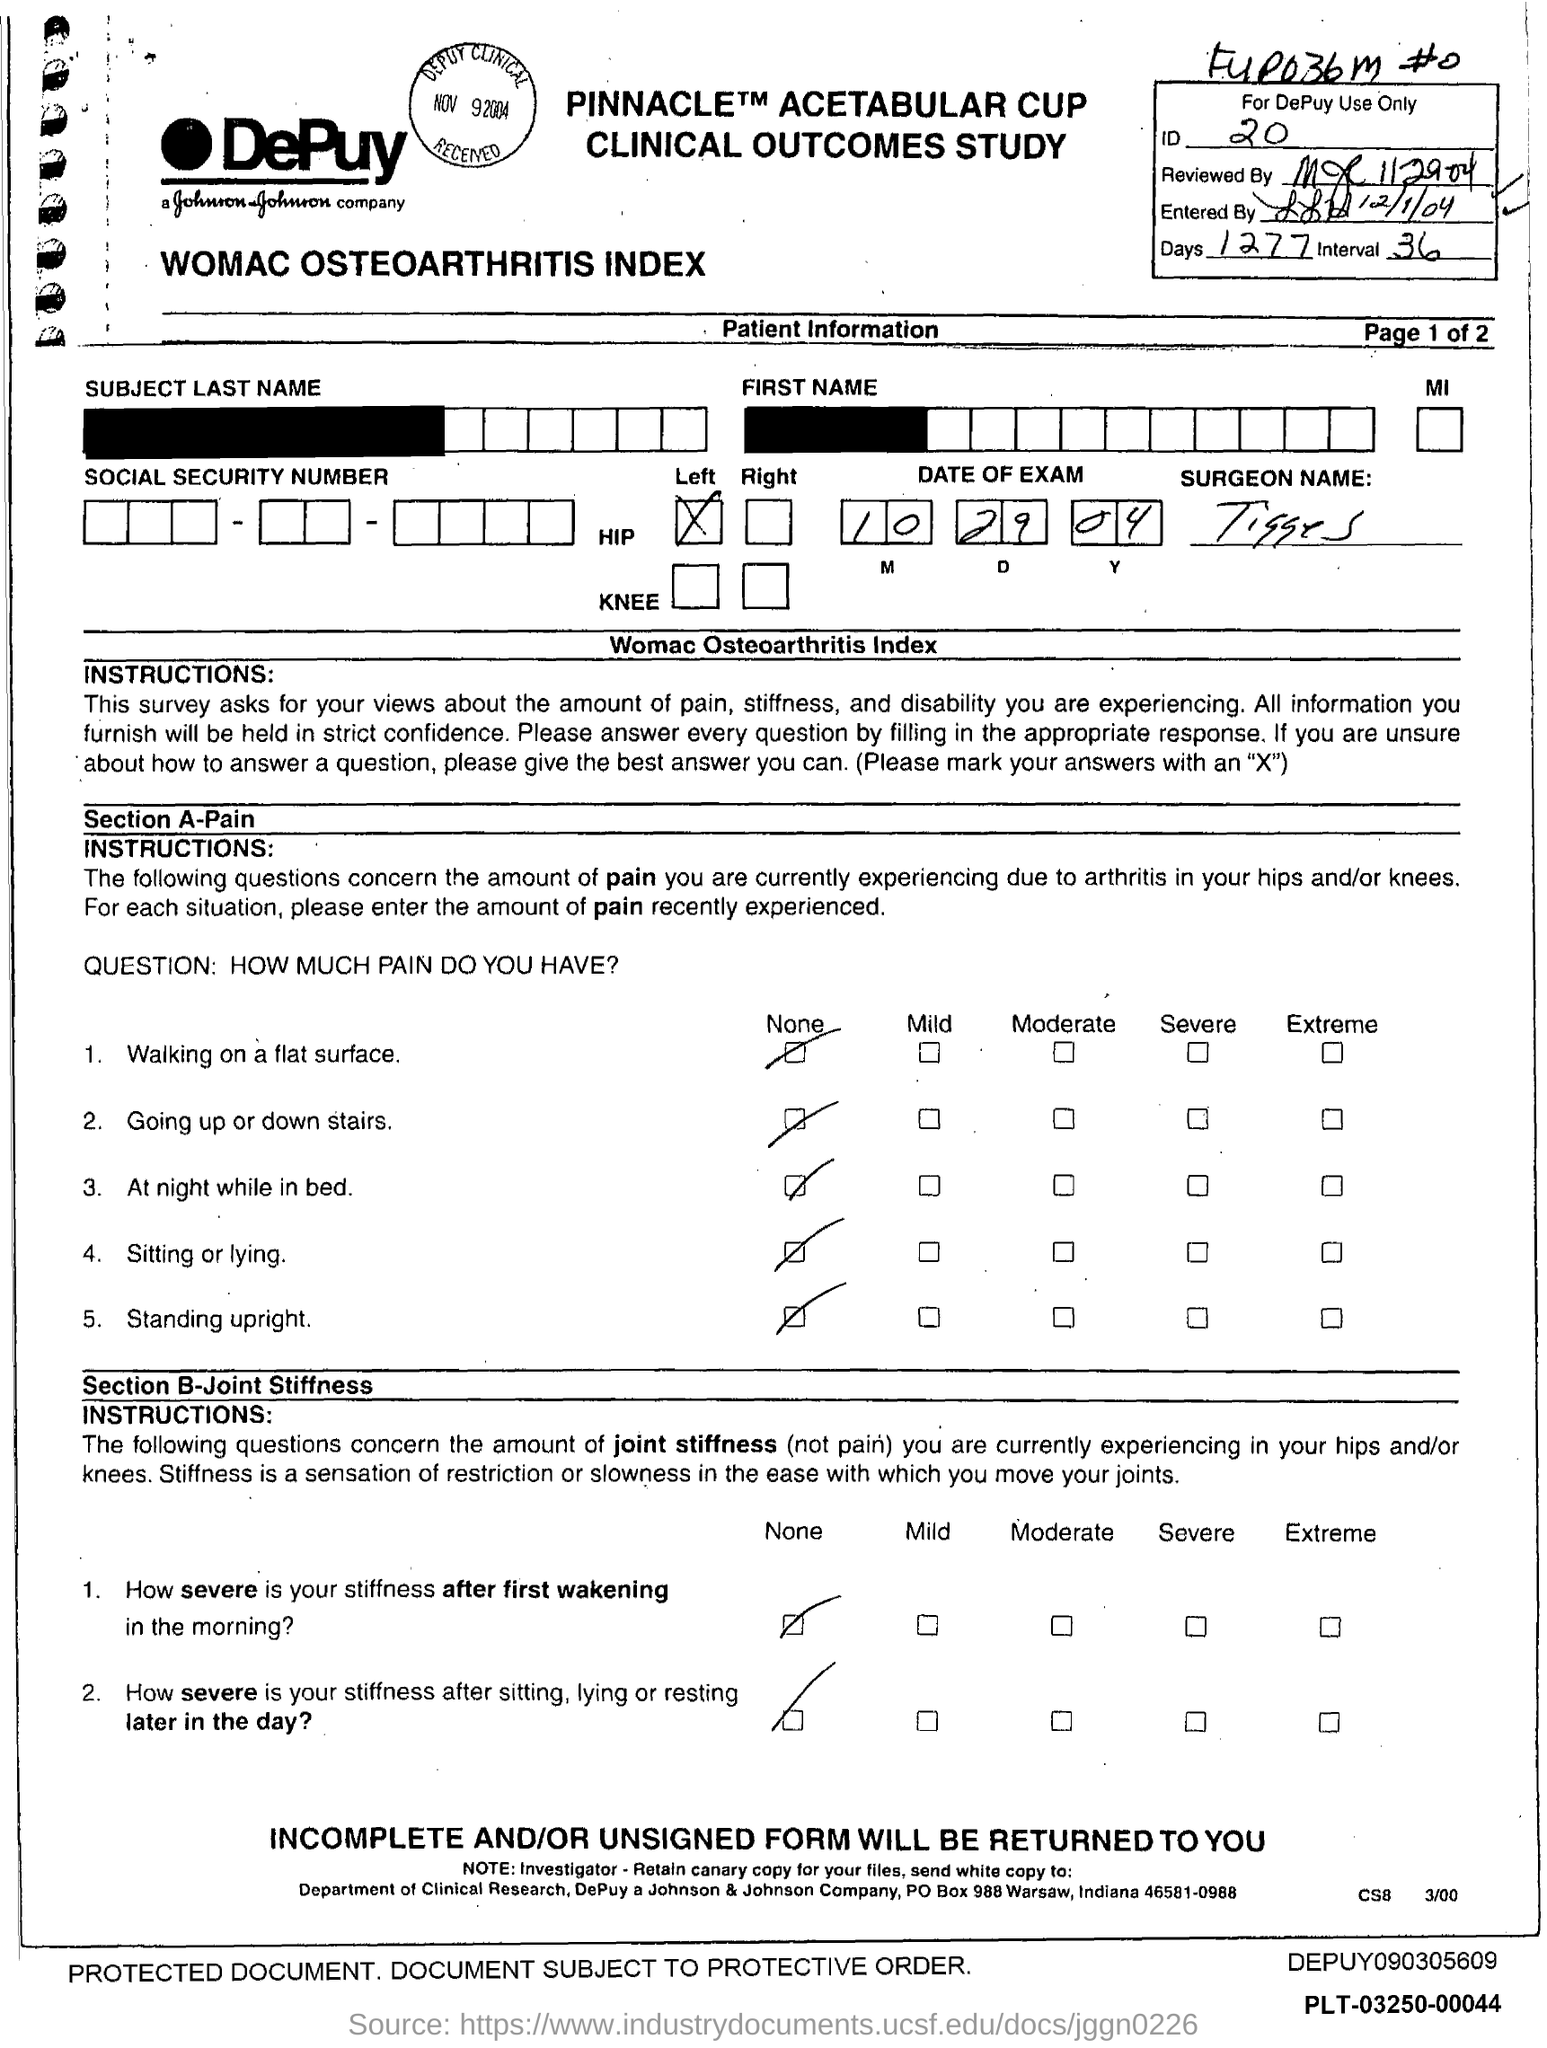What is the number of days?
Your response must be concise. 1277. What is the ID Number?
Offer a terse response. 20. 